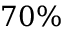Convert formula to latex. <formula><loc_0><loc_0><loc_500><loc_500>7 0 \%</formula> 